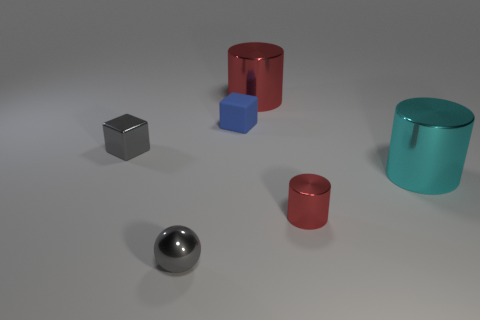Could you estimate the size of these objects? Without clear reference points, it's difficult to estimate their exact size, but they seem to resemble typical shapes that could fit comfortably in the palm of a hand. 